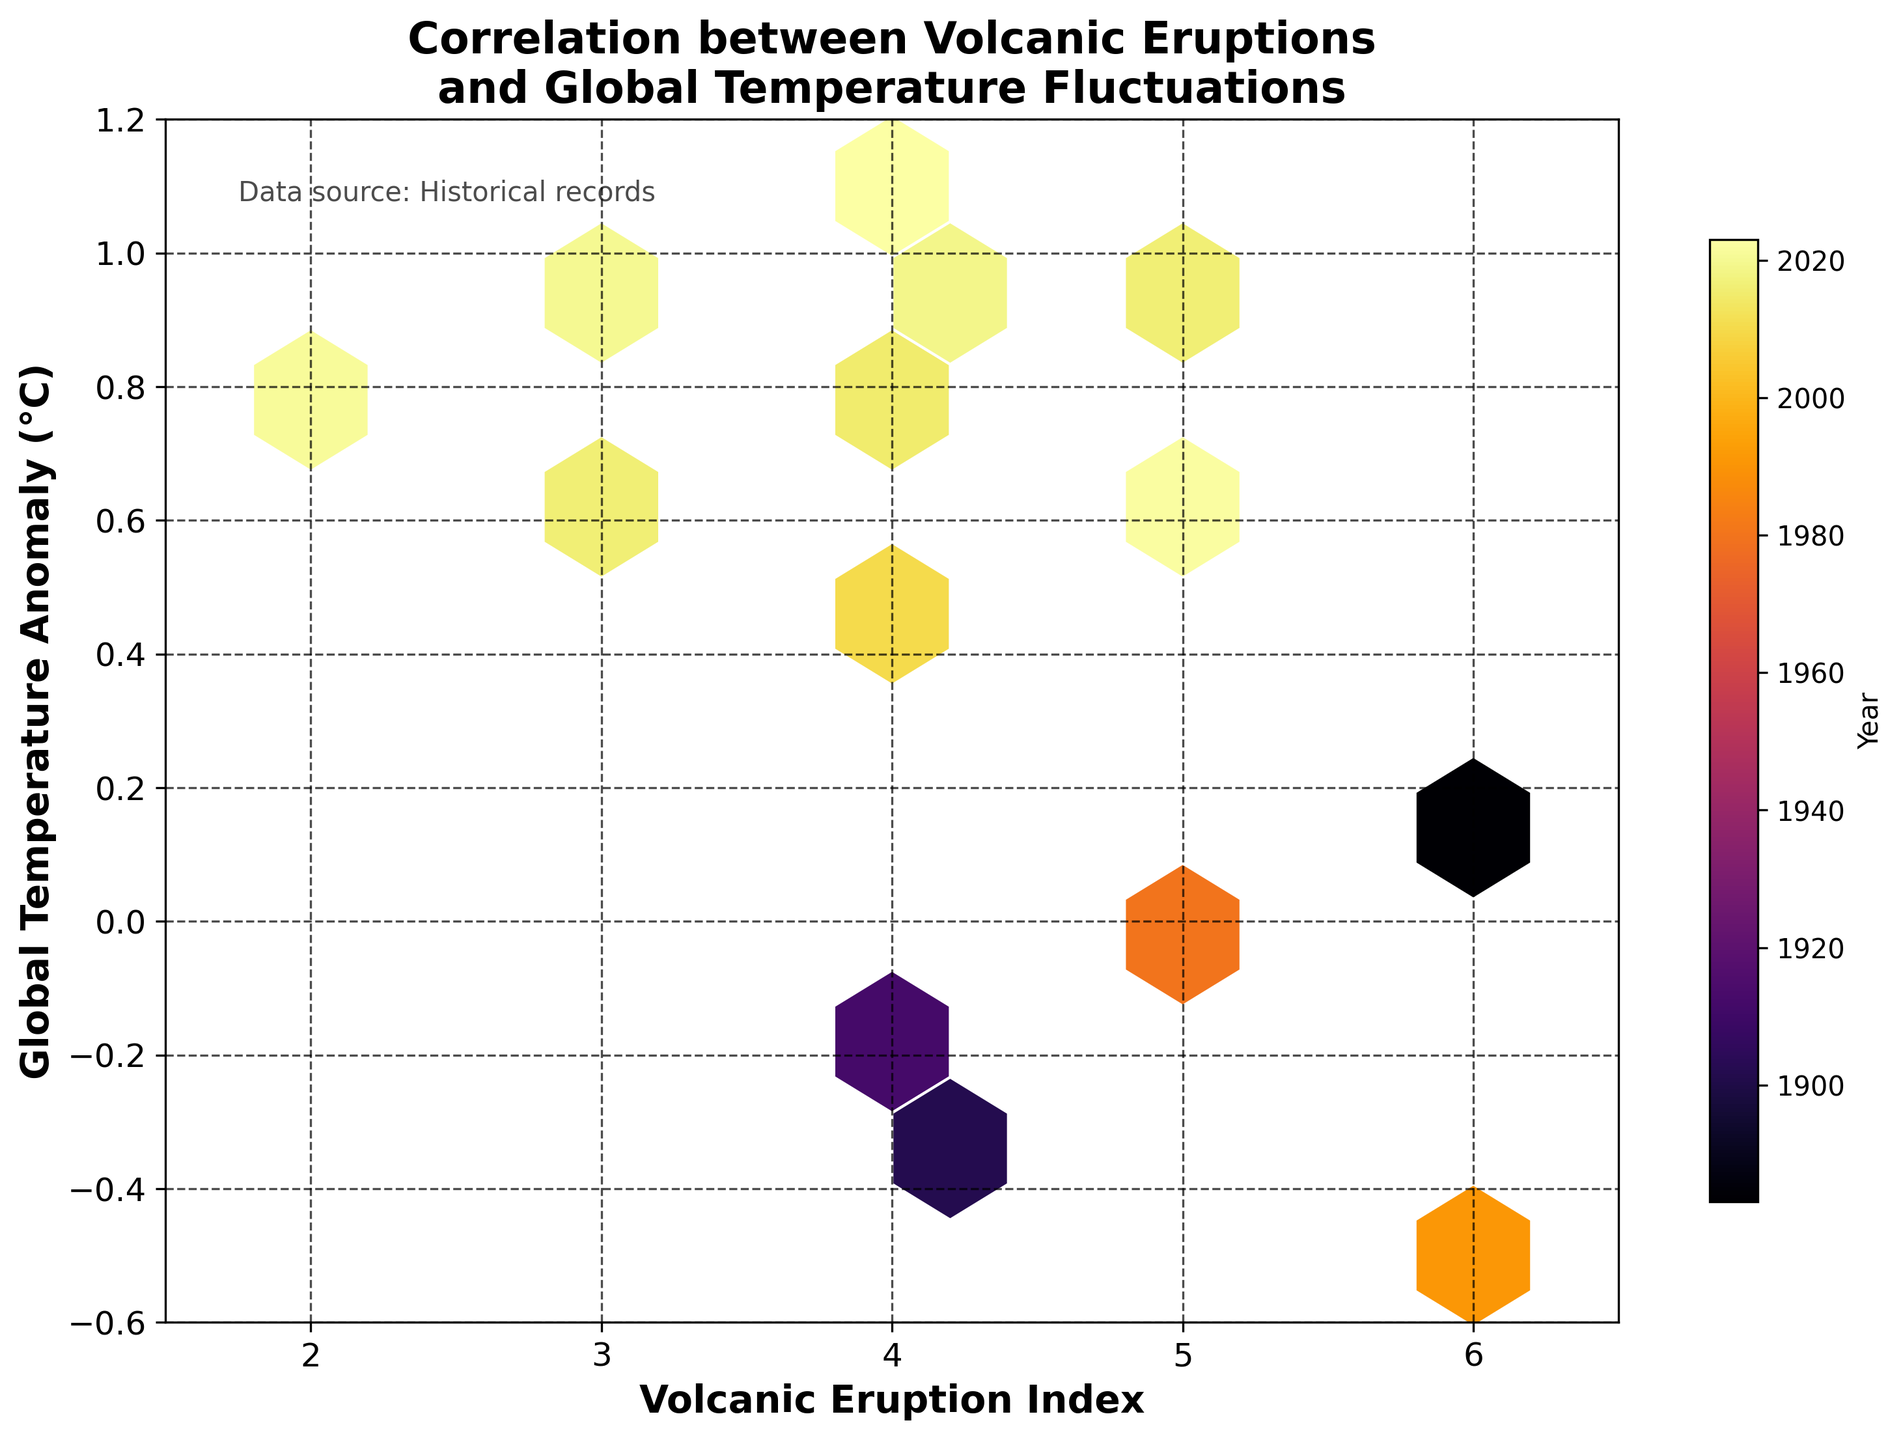What is the title of the hexbin plot? The title of the hexbin plot is announced at the top center of the figure. It helps to understand the subject of the plot.
Answer: Correlation between Volcanic Eruptions and Global Temperature Fluctuations What do the axes represent? The x-axis represents the 'Volcanic Eruption Index,' and the y-axis represents the 'Global Temperature Anomaly (°C).' This can be observed from the labels on the respective axes.
Answer: Volcanic Eruption Index and Global Temperature Anomaly (°C) What kind of color map is used in the hexbin plot? The color map used is 'inferno,' which is visually perceptible from the color gradient on the plot and color bar.
Answer: inferno What is the range of the Global Temperature Anomaly values depicted on the y-axis? The range of the Global Temperature Anomaly values can be observed from the y-axis ticks. They range from -0.6 to 1.2.
Answer: -0.6 to 1.2 How many hexagonal bins does the plot use for the grid size? The gridsize of the hexagonal bins is mentioned in the code used to generate the plot. The plot utilizes a gridsize of 10.
Answer: 10 In which year did the highest volcanic eruption index occur? By observing the colors associated with hexagons and their relation to the color bar, the hexagon corresponding to 1991 is the darkest, indicating the highest eruption index of 6.
Answer: 1991 What is the relationship between volcanic eruption index and global temperature anomaly based on the plot? We can observe clustering at lower temperature anomalies for higher eruption indices, indicating a possible negative correlation. Higher eruption indices generally correspond to lower or negative global temperature anomalies.
Answer: Negative correlation Locate the highest global temperature anomaly in the plot and identify the corresponding year and eruption index. By finding the hexagon positioned at the highest point on the y-axis (1.1), we use the color bar to determine it corresponds to the year 2023. The eruption index for this point is 4.
Answer: 2023, 4 Compare the global temperature anomalies before and after 1980. What trend do you observe? Pre-1980 data points (e.g., 1883, 1902, 1912) generally have lower temperature anomalies ranging from -0.5 to 0.2. Post-1980, there's a noticeable increase in global temperature anomalies with most points ranging from -0.1 to 1.1.
Answer: Increasing trend What does the color bar in the plot indicate? The color bar on the right side of the plot represents the years of the recorded data points, where the color intensity correlates with more recent years.
Answer: Year 